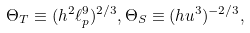<formula> <loc_0><loc_0><loc_500><loc_500>\Theta _ { T } \equiv ( h ^ { 2 } \ell _ { p } ^ { 9 } ) ^ { 2 / 3 } , \Theta _ { S } \equiv ( h u ^ { 3 } ) ^ { - 2 / 3 } ,</formula> 